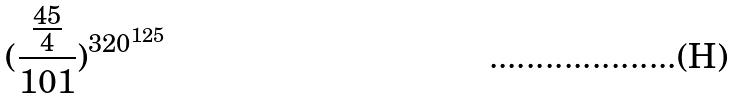<formula> <loc_0><loc_0><loc_500><loc_500>( \frac { \frac { 4 5 } { 4 } } { 1 0 1 } ) ^ { 3 2 0 ^ { 1 2 5 } }</formula> 